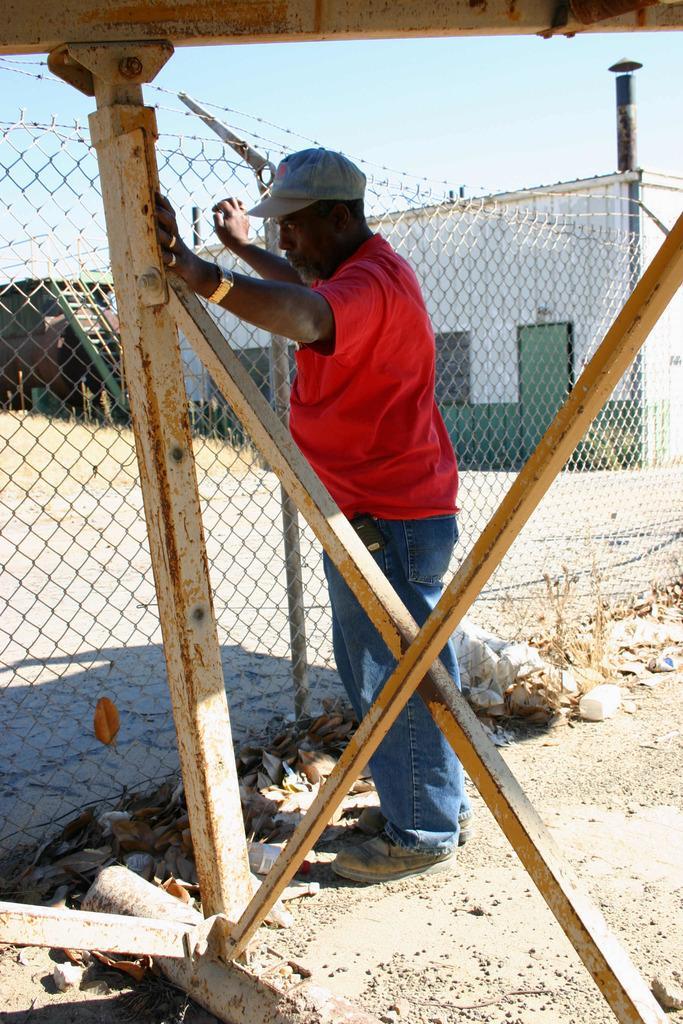How would you summarize this image in a sentence or two? In this image I can see the person is standing and wearing red and blue color dress. I can see the net fencing, few objects, iron poles and few houses. 